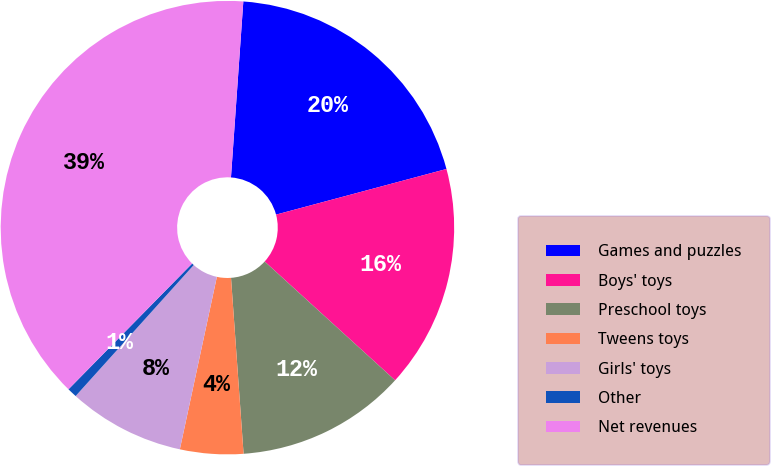Convert chart. <chart><loc_0><loc_0><loc_500><loc_500><pie_chart><fcel>Games and puzzles<fcel>Boys' toys<fcel>Preschool toys<fcel>Tweens toys<fcel>Girls' toys<fcel>Other<fcel>Net revenues<nl><fcel>19.72%<fcel>15.92%<fcel>12.11%<fcel>4.5%<fcel>8.31%<fcel>0.69%<fcel>38.75%<nl></chart> 